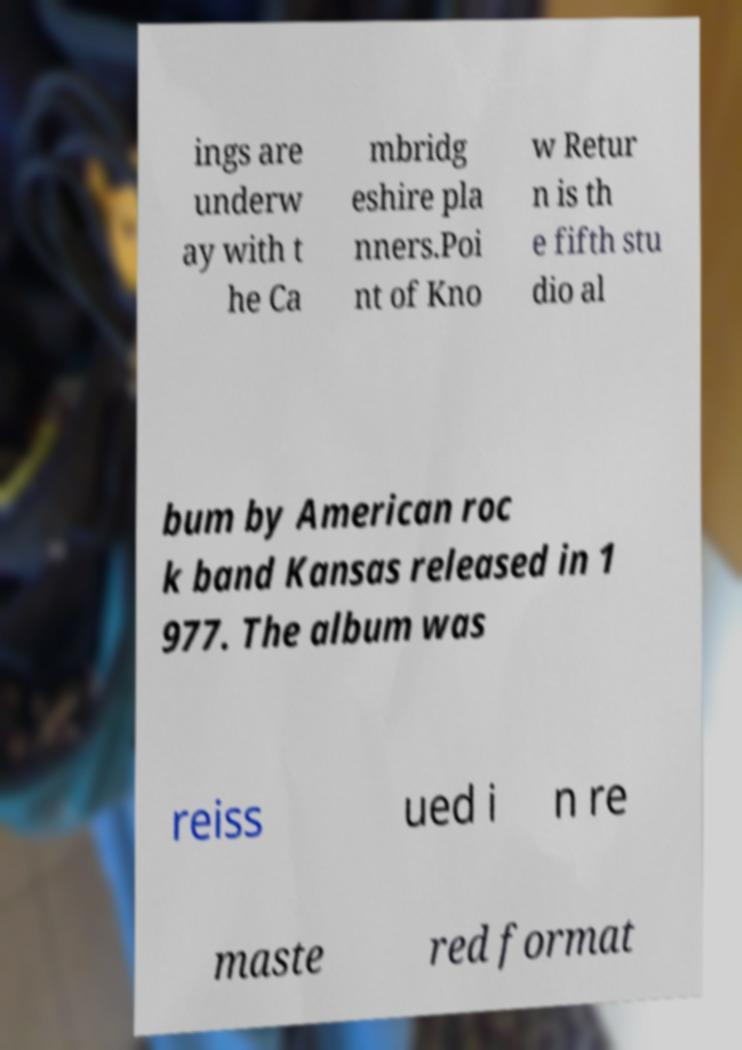I need the written content from this picture converted into text. Can you do that? ings are underw ay with t he Ca mbridg eshire pla nners.Poi nt of Kno w Retur n is th e fifth stu dio al bum by American roc k band Kansas released in 1 977. The album was reiss ued i n re maste red format 